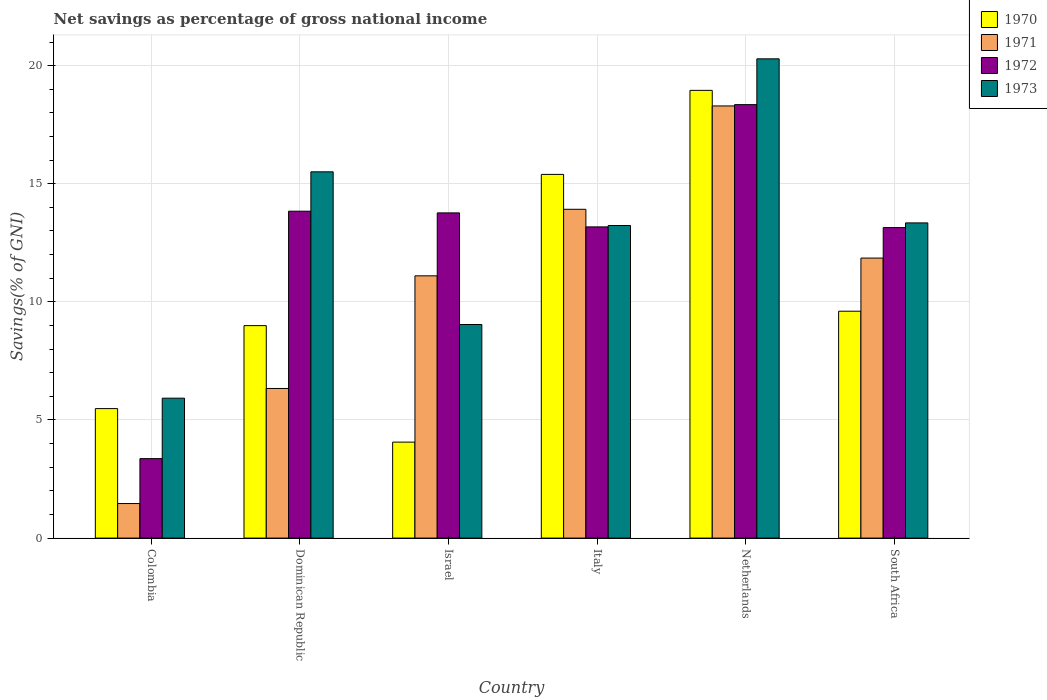How many different coloured bars are there?
Your answer should be compact. 4. Are the number of bars on each tick of the X-axis equal?
Make the answer very short. Yes. What is the label of the 2nd group of bars from the left?
Provide a succinct answer. Dominican Republic. What is the total savings in 1970 in Colombia?
Provide a succinct answer. 5.48. Across all countries, what is the maximum total savings in 1972?
Keep it short and to the point. 18.35. Across all countries, what is the minimum total savings in 1970?
Make the answer very short. 4.06. In which country was the total savings in 1971 maximum?
Provide a short and direct response. Netherlands. What is the total total savings in 1970 in the graph?
Your answer should be compact. 62.49. What is the difference between the total savings in 1973 in Colombia and that in Italy?
Provide a succinct answer. -7.31. What is the difference between the total savings in 1973 in Colombia and the total savings in 1970 in Dominican Republic?
Offer a terse response. -3.07. What is the average total savings in 1970 per country?
Your answer should be very brief. 10.42. What is the difference between the total savings of/in 1973 and total savings of/in 1970 in Colombia?
Make the answer very short. 0.44. What is the ratio of the total savings in 1972 in Colombia to that in South Africa?
Provide a short and direct response. 0.26. Is the total savings in 1970 in Italy less than that in Netherlands?
Your answer should be compact. Yes. What is the difference between the highest and the second highest total savings in 1970?
Your response must be concise. -9.35. What is the difference between the highest and the lowest total savings in 1973?
Provide a short and direct response. 14.36. Is the sum of the total savings in 1973 in Colombia and Israel greater than the maximum total savings in 1970 across all countries?
Make the answer very short. No. Is it the case that in every country, the sum of the total savings in 1971 and total savings in 1973 is greater than the sum of total savings in 1970 and total savings in 1972?
Offer a terse response. No. What does the 4th bar from the left in South Africa represents?
Keep it short and to the point. 1973. Are the values on the major ticks of Y-axis written in scientific E-notation?
Make the answer very short. No. What is the title of the graph?
Your answer should be compact. Net savings as percentage of gross national income. Does "2014" appear as one of the legend labels in the graph?
Your answer should be compact. No. What is the label or title of the Y-axis?
Ensure brevity in your answer.  Savings(% of GNI). What is the Savings(% of GNI) in 1970 in Colombia?
Offer a terse response. 5.48. What is the Savings(% of GNI) of 1971 in Colombia?
Provide a short and direct response. 1.46. What is the Savings(% of GNI) in 1972 in Colombia?
Your answer should be compact. 3.36. What is the Savings(% of GNI) in 1973 in Colombia?
Your answer should be compact. 5.92. What is the Savings(% of GNI) of 1970 in Dominican Republic?
Make the answer very short. 8.99. What is the Savings(% of GNI) in 1971 in Dominican Republic?
Provide a short and direct response. 6.33. What is the Savings(% of GNI) of 1972 in Dominican Republic?
Provide a short and direct response. 13.84. What is the Savings(% of GNI) in 1973 in Dominican Republic?
Offer a very short reply. 15.5. What is the Savings(% of GNI) of 1970 in Israel?
Your response must be concise. 4.06. What is the Savings(% of GNI) of 1971 in Israel?
Offer a very short reply. 11.1. What is the Savings(% of GNI) in 1972 in Israel?
Offer a very short reply. 13.77. What is the Savings(% of GNI) in 1973 in Israel?
Your response must be concise. 9.04. What is the Savings(% of GNI) of 1970 in Italy?
Make the answer very short. 15.4. What is the Savings(% of GNI) of 1971 in Italy?
Keep it short and to the point. 13.92. What is the Savings(% of GNI) of 1972 in Italy?
Offer a very short reply. 13.17. What is the Savings(% of GNI) in 1973 in Italy?
Your answer should be very brief. 13.23. What is the Savings(% of GNI) of 1970 in Netherlands?
Give a very brief answer. 18.95. What is the Savings(% of GNI) in 1971 in Netherlands?
Offer a very short reply. 18.29. What is the Savings(% of GNI) of 1972 in Netherlands?
Offer a terse response. 18.35. What is the Savings(% of GNI) of 1973 in Netherlands?
Your answer should be very brief. 20.29. What is the Savings(% of GNI) in 1970 in South Africa?
Your answer should be compact. 9.6. What is the Savings(% of GNI) of 1971 in South Africa?
Ensure brevity in your answer.  11.85. What is the Savings(% of GNI) in 1972 in South Africa?
Offer a terse response. 13.14. What is the Savings(% of GNI) of 1973 in South Africa?
Give a very brief answer. 13.34. Across all countries, what is the maximum Savings(% of GNI) in 1970?
Your response must be concise. 18.95. Across all countries, what is the maximum Savings(% of GNI) of 1971?
Your answer should be very brief. 18.29. Across all countries, what is the maximum Savings(% of GNI) of 1972?
Make the answer very short. 18.35. Across all countries, what is the maximum Savings(% of GNI) of 1973?
Provide a short and direct response. 20.29. Across all countries, what is the minimum Savings(% of GNI) of 1970?
Make the answer very short. 4.06. Across all countries, what is the minimum Savings(% of GNI) of 1971?
Your answer should be compact. 1.46. Across all countries, what is the minimum Savings(% of GNI) in 1972?
Offer a terse response. 3.36. Across all countries, what is the minimum Savings(% of GNI) of 1973?
Your answer should be very brief. 5.92. What is the total Savings(% of GNI) of 1970 in the graph?
Your response must be concise. 62.49. What is the total Savings(% of GNI) in 1971 in the graph?
Offer a very short reply. 62.96. What is the total Savings(% of GNI) in 1972 in the graph?
Keep it short and to the point. 75.63. What is the total Savings(% of GNI) of 1973 in the graph?
Provide a short and direct response. 77.33. What is the difference between the Savings(% of GNI) in 1970 in Colombia and that in Dominican Republic?
Your answer should be very brief. -3.51. What is the difference between the Savings(% of GNI) of 1971 in Colombia and that in Dominican Republic?
Your answer should be very brief. -4.87. What is the difference between the Savings(% of GNI) in 1972 in Colombia and that in Dominican Republic?
Your answer should be compact. -10.47. What is the difference between the Savings(% of GNI) in 1973 in Colombia and that in Dominican Republic?
Your answer should be compact. -9.58. What is the difference between the Savings(% of GNI) of 1970 in Colombia and that in Israel?
Keep it short and to the point. 1.42. What is the difference between the Savings(% of GNI) of 1971 in Colombia and that in Israel?
Keep it short and to the point. -9.64. What is the difference between the Savings(% of GNI) in 1972 in Colombia and that in Israel?
Ensure brevity in your answer.  -10.4. What is the difference between the Savings(% of GNI) in 1973 in Colombia and that in Israel?
Ensure brevity in your answer.  -3.12. What is the difference between the Savings(% of GNI) in 1970 in Colombia and that in Italy?
Your answer should be very brief. -9.91. What is the difference between the Savings(% of GNI) of 1971 in Colombia and that in Italy?
Make the answer very short. -12.46. What is the difference between the Savings(% of GNI) of 1972 in Colombia and that in Italy?
Offer a terse response. -9.81. What is the difference between the Savings(% of GNI) in 1973 in Colombia and that in Italy?
Offer a terse response. -7.31. What is the difference between the Savings(% of GNI) in 1970 in Colombia and that in Netherlands?
Ensure brevity in your answer.  -13.47. What is the difference between the Savings(% of GNI) in 1971 in Colombia and that in Netherlands?
Ensure brevity in your answer.  -16.83. What is the difference between the Savings(% of GNI) of 1972 in Colombia and that in Netherlands?
Your answer should be very brief. -14.99. What is the difference between the Savings(% of GNI) of 1973 in Colombia and that in Netherlands?
Your response must be concise. -14.36. What is the difference between the Savings(% of GNI) of 1970 in Colombia and that in South Africa?
Make the answer very short. -4.12. What is the difference between the Savings(% of GNI) in 1971 in Colombia and that in South Africa?
Provide a short and direct response. -10.39. What is the difference between the Savings(% of GNI) of 1972 in Colombia and that in South Africa?
Your response must be concise. -9.78. What is the difference between the Savings(% of GNI) in 1973 in Colombia and that in South Africa?
Keep it short and to the point. -7.42. What is the difference between the Savings(% of GNI) in 1970 in Dominican Republic and that in Israel?
Keep it short and to the point. 4.93. What is the difference between the Savings(% of GNI) of 1971 in Dominican Republic and that in Israel?
Your answer should be compact. -4.77. What is the difference between the Savings(% of GNI) of 1972 in Dominican Republic and that in Israel?
Provide a short and direct response. 0.07. What is the difference between the Savings(% of GNI) in 1973 in Dominican Republic and that in Israel?
Your answer should be very brief. 6.46. What is the difference between the Savings(% of GNI) in 1970 in Dominican Republic and that in Italy?
Your answer should be compact. -6.4. What is the difference between the Savings(% of GNI) of 1971 in Dominican Republic and that in Italy?
Offer a very short reply. -7.59. What is the difference between the Savings(% of GNI) of 1972 in Dominican Republic and that in Italy?
Your response must be concise. 0.66. What is the difference between the Savings(% of GNI) in 1973 in Dominican Republic and that in Italy?
Offer a terse response. 2.27. What is the difference between the Savings(% of GNI) in 1970 in Dominican Republic and that in Netherlands?
Make the answer very short. -9.96. What is the difference between the Savings(% of GNI) in 1971 in Dominican Republic and that in Netherlands?
Your response must be concise. -11.96. What is the difference between the Savings(% of GNI) of 1972 in Dominican Republic and that in Netherlands?
Give a very brief answer. -4.51. What is the difference between the Savings(% of GNI) in 1973 in Dominican Republic and that in Netherlands?
Keep it short and to the point. -4.78. What is the difference between the Savings(% of GNI) of 1970 in Dominican Republic and that in South Africa?
Your response must be concise. -0.61. What is the difference between the Savings(% of GNI) of 1971 in Dominican Republic and that in South Africa?
Offer a terse response. -5.52. What is the difference between the Savings(% of GNI) of 1972 in Dominican Republic and that in South Africa?
Provide a succinct answer. 0.69. What is the difference between the Savings(% of GNI) of 1973 in Dominican Republic and that in South Africa?
Keep it short and to the point. 2.16. What is the difference between the Savings(% of GNI) of 1970 in Israel and that in Italy?
Make the answer very short. -11.33. What is the difference between the Savings(% of GNI) of 1971 in Israel and that in Italy?
Your answer should be very brief. -2.82. What is the difference between the Savings(% of GNI) of 1972 in Israel and that in Italy?
Ensure brevity in your answer.  0.59. What is the difference between the Savings(% of GNI) in 1973 in Israel and that in Italy?
Offer a very short reply. -4.19. What is the difference between the Savings(% of GNI) in 1970 in Israel and that in Netherlands?
Your response must be concise. -14.89. What is the difference between the Savings(% of GNI) of 1971 in Israel and that in Netherlands?
Offer a terse response. -7.19. What is the difference between the Savings(% of GNI) in 1972 in Israel and that in Netherlands?
Keep it short and to the point. -4.58. What is the difference between the Savings(% of GNI) of 1973 in Israel and that in Netherlands?
Ensure brevity in your answer.  -11.25. What is the difference between the Savings(% of GNI) of 1970 in Israel and that in South Africa?
Make the answer very short. -5.54. What is the difference between the Savings(% of GNI) of 1971 in Israel and that in South Africa?
Offer a very short reply. -0.75. What is the difference between the Savings(% of GNI) of 1972 in Israel and that in South Africa?
Ensure brevity in your answer.  0.62. What is the difference between the Savings(% of GNI) in 1973 in Israel and that in South Africa?
Ensure brevity in your answer.  -4.3. What is the difference between the Savings(% of GNI) in 1970 in Italy and that in Netherlands?
Make the answer very short. -3.56. What is the difference between the Savings(% of GNI) in 1971 in Italy and that in Netherlands?
Make the answer very short. -4.37. What is the difference between the Savings(% of GNI) in 1972 in Italy and that in Netherlands?
Ensure brevity in your answer.  -5.18. What is the difference between the Savings(% of GNI) in 1973 in Italy and that in Netherlands?
Offer a very short reply. -7.06. What is the difference between the Savings(% of GNI) of 1970 in Italy and that in South Africa?
Make the answer very short. 5.79. What is the difference between the Savings(% of GNI) of 1971 in Italy and that in South Africa?
Offer a terse response. 2.07. What is the difference between the Savings(% of GNI) in 1972 in Italy and that in South Africa?
Your answer should be very brief. 0.03. What is the difference between the Savings(% of GNI) in 1973 in Italy and that in South Africa?
Keep it short and to the point. -0.11. What is the difference between the Savings(% of GNI) in 1970 in Netherlands and that in South Africa?
Make the answer very short. 9.35. What is the difference between the Savings(% of GNI) in 1971 in Netherlands and that in South Africa?
Your response must be concise. 6.44. What is the difference between the Savings(% of GNI) of 1972 in Netherlands and that in South Africa?
Provide a short and direct response. 5.21. What is the difference between the Savings(% of GNI) of 1973 in Netherlands and that in South Africa?
Give a very brief answer. 6.95. What is the difference between the Savings(% of GNI) of 1970 in Colombia and the Savings(% of GNI) of 1971 in Dominican Republic?
Ensure brevity in your answer.  -0.85. What is the difference between the Savings(% of GNI) in 1970 in Colombia and the Savings(% of GNI) in 1972 in Dominican Republic?
Give a very brief answer. -8.36. What is the difference between the Savings(% of GNI) in 1970 in Colombia and the Savings(% of GNI) in 1973 in Dominican Republic?
Keep it short and to the point. -10.02. What is the difference between the Savings(% of GNI) in 1971 in Colombia and the Savings(% of GNI) in 1972 in Dominican Republic?
Your response must be concise. -12.38. What is the difference between the Savings(% of GNI) in 1971 in Colombia and the Savings(% of GNI) in 1973 in Dominican Republic?
Provide a short and direct response. -14.04. What is the difference between the Savings(% of GNI) in 1972 in Colombia and the Savings(% of GNI) in 1973 in Dominican Republic?
Make the answer very short. -12.14. What is the difference between the Savings(% of GNI) in 1970 in Colombia and the Savings(% of GNI) in 1971 in Israel?
Offer a terse response. -5.62. What is the difference between the Savings(% of GNI) in 1970 in Colombia and the Savings(% of GNI) in 1972 in Israel?
Your answer should be compact. -8.28. What is the difference between the Savings(% of GNI) of 1970 in Colombia and the Savings(% of GNI) of 1973 in Israel?
Your answer should be compact. -3.56. What is the difference between the Savings(% of GNI) in 1971 in Colombia and the Savings(% of GNI) in 1972 in Israel?
Ensure brevity in your answer.  -12.3. What is the difference between the Savings(% of GNI) of 1971 in Colombia and the Savings(% of GNI) of 1973 in Israel?
Give a very brief answer. -7.58. What is the difference between the Savings(% of GNI) in 1972 in Colombia and the Savings(% of GNI) in 1973 in Israel?
Give a very brief answer. -5.68. What is the difference between the Savings(% of GNI) of 1970 in Colombia and the Savings(% of GNI) of 1971 in Italy?
Keep it short and to the point. -8.44. What is the difference between the Savings(% of GNI) in 1970 in Colombia and the Savings(% of GNI) in 1972 in Italy?
Give a very brief answer. -7.69. What is the difference between the Savings(% of GNI) of 1970 in Colombia and the Savings(% of GNI) of 1973 in Italy?
Offer a terse response. -7.75. What is the difference between the Savings(% of GNI) in 1971 in Colombia and the Savings(% of GNI) in 1972 in Italy?
Your answer should be compact. -11.71. What is the difference between the Savings(% of GNI) in 1971 in Colombia and the Savings(% of GNI) in 1973 in Italy?
Keep it short and to the point. -11.77. What is the difference between the Savings(% of GNI) of 1972 in Colombia and the Savings(% of GNI) of 1973 in Italy?
Provide a short and direct response. -9.87. What is the difference between the Savings(% of GNI) in 1970 in Colombia and the Savings(% of GNI) in 1971 in Netherlands?
Provide a succinct answer. -12.81. What is the difference between the Savings(% of GNI) in 1970 in Colombia and the Savings(% of GNI) in 1972 in Netherlands?
Offer a terse response. -12.87. What is the difference between the Savings(% of GNI) of 1970 in Colombia and the Savings(% of GNI) of 1973 in Netherlands?
Offer a terse response. -14.81. What is the difference between the Savings(% of GNI) in 1971 in Colombia and the Savings(% of GNI) in 1972 in Netherlands?
Make the answer very short. -16.89. What is the difference between the Savings(% of GNI) of 1971 in Colombia and the Savings(% of GNI) of 1973 in Netherlands?
Offer a terse response. -18.83. What is the difference between the Savings(% of GNI) of 1972 in Colombia and the Savings(% of GNI) of 1973 in Netherlands?
Give a very brief answer. -16.92. What is the difference between the Savings(% of GNI) of 1970 in Colombia and the Savings(% of GNI) of 1971 in South Africa?
Your answer should be very brief. -6.37. What is the difference between the Savings(% of GNI) in 1970 in Colombia and the Savings(% of GNI) in 1972 in South Africa?
Offer a very short reply. -7.66. What is the difference between the Savings(% of GNI) of 1970 in Colombia and the Savings(% of GNI) of 1973 in South Africa?
Provide a succinct answer. -7.86. What is the difference between the Savings(% of GNI) in 1971 in Colombia and the Savings(% of GNI) in 1972 in South Africa?
Ensure brevity in your answer.  -11.68. What is the difference between the Savings(% of GNI) in 1971 in Colombia and the Savings(% of GNI) in 1973 in South Africa?
Offer a very short reply. -11.88. What is the difference between the Savings(% of GNI) in 1972 in Colombia and the Savings(% of GNI) in 1973 in South Africa?
Offer a terse response. -9.98. What is the difference between the Savings(% of GNI) in 1970 in Dominican Republic and the Savings(% of GNI) in 1971 in Israel?
Keep it short and to the point. -2.11. What is the difference between the Savings(% of GNI) of 1970 in Dominican Republic and the Savings(% of GNI) of 1972 in Israel?
Your answer should be very brief. -4.77. What is the difference between the Savings(% of GNI) in 1970 in Dominican Republic and the Savings(% of GNI) in 1973 in Israel?
Your answer should be compact. -0.05. What is the difference between the Savings(% of GNI) in 1971 in Dominican Republic and the Savings(% of GNI) in 1972 in Israel?
Offer a very short reply. -7.43. What is the difference between the Savings(% of GNI) in 1971 in Dominican Republic and the Savings(% of GNI) in 1973 in Israel?
Ensure brevity in your answer.  -2.71. What is the difference between the Savings(% of GNI) in 1972 in Dominican Republic and the Savings(% of GNI) in 1973 in Israel?
Your answer should be compact. 4.8. What is the difference between the Savings(% of GNI) in 1970 in Dominican Republic and the Savings(% of GNI) in 1971 in Italy?
Ensure brevity in your answer.  -4.93. What is the difference between the Savings(% of GNI) in 1970 in Dominican Republic and the Savings(% of GNI) in 1972 in Italy?
Keep it short and to the point. -4.18. What is the difference between the Savings(% of GNI) in 1970 in Dominican Republic and the Savings(% of GNI) in 1973 in Italy?
Provide a short and direct response. -4.24. What is the difference between the Savings(% of GNI) of 1971 in Dominican Republic and the Savings(% of GNI) of 1972 in Italy?
Give a very brief answer. -6.84. What is the difference between the Savings(% of GNI) of 1971 in Dominican Republic and the Savings(% of GNI) of 1973 in Italy?
Offer a terse response. -6.9. What is the difference between the Savings(% of GNI) of 1972 in Dominican Republic and the Savings(% of GNI) of 1973 in Italy?
Your answer should be compact. 0.61. What is the difference between the Savings(% of GNI) in 1970 in Dominican Republic and the Savings(% of GNI) in 1971 in Netherlands?
Ensure brevity in your answer.  -9.3. What is the difference between the Savings(% of GNI) in 1970 in Dominican Republic and the Savings(% of GNI) in 1972 in Netherlands?
Provide a succinct answer. -9.36. What is the difference between the Savings(% of GNI) in 1970 in Dominican Republic and the Savings(% of GNI) in 1973 in Netherlands?
Offer a very short reply. -11.29. What is the difference between the Savings(% of GNI) in 1971 in Dominican Republic and the Savings(% of GNI) in 1972 in Netherlands?
Offer a terse response. -12.02. What is the difference between the Savings(% of GNI) of 1971 in Dominican Republic and the Savings(% of GNI) of 1973 in Netherlands?
Provide a succinct answer. -13.95. What is the difference between the Savings(% of GNI) of 1972 in Dominican Republic and the Savings(% of GNI) of 1973 in Netherlands?
Keep it short and to the point. -6.45. What is the difference between the Savings(% of GNI) of 1970 in Dominican Republic and the Savings(% of GNI) of 1971 in South Africa?
Your answer should be very brief. -2.86. What is the difference between the Savings(% of GNI) of 1970 in Dominican Republic and the Savings(% of GNI) of 1972 in South Africa?
Make the answer very short. -4.15. What is the difference between the Savings(% of GNI) of 1970 in Dominican Republic and the Savings(% of GNI) of 1973 in South Africa?
Your answer should be compact. -4.35. What is the difference between the Savings(% of GNI) in 1971 in Dominican Republic and the Savings(% of GNI) in 1972 in South Africa?
Your answer should be very brief. -6.81. What is the difference between the Savings(% of GNI) of 1971 in Dominican Republic and the Savings(% of GNI) of 1973 in South Africa?
Your answer should be compact. -7.01. What is the difference between the Savings(% of GNI) in 1972 in Dominican Republic and the Savings(% of GNI) in 1973 in South Africa?
Ensure brevity in your answer.  0.5. What is the difference between the Savings(% of GNI) of 1970 in Israel and the Savings(% of GNI) of 1971 in Italy?
Give a very brief answer. -9.86. What is the difference between the Savings(% of GNI) of 1970 in Israel and the Savings(% of GNI) of 1972 in Italy?
Offer a terse response. -9.11. What is the difference between the Savings(% of GNI) in 1970 in Israel and the Savings(% of GNI) in 1973 in Italy?
Ensure brevity in your answer.  -9.17. What is the difference between the Savings(% of GNI) in 1971 in Israel and the Savings(% of GNI) in 1972 in Italy?
Your answer should be very brief. -2.07. What is the difference between the Savings(% of GNI) of 1971 in Israel and the Savings(% of GNI) of 1973 in Italy?
Your answer should be compact. -2.13. What is the difference between the Savings(% of GNI) in 1972 in Israel and the Savings(% of GNI) in 1973 in Italy?
Offer a terse response. 0.53. What is the difference between the Savings(% of GNI) in 1970 in Israel and the Savings(% of GNI) in 1971 in Netherlands?
Keep it short and to the point. -14.23. What is the difference between the Savings(% of GNI) of 1970 in Israel and the Savings(% of GNI) of 1972 in Netherlands?
Ensure brevity in your answer.  -14.29. What is the difference between the Savings(% of GNI) in 1970 in Israel and the Savings(% of GNI) in 1973 in Netherlands?
Make the answer very short. -16.22. What is the difference between the Savings(% of GNI) in 1971 in Israel and the Savings(% of GNI) in 1972 in Netherlands?
Your response must be concise. -7.25. What is the difference between the Savings(% of GNI) in 1971 in Israel and the Savings(% of GNI) in 1973 in Netherlands?
Keep it short and to the point. -9.19. What is the difference between the Savings(% of GNI) in 1972 in Israel and the Savings(% of GNI) in 1973 in Netherlands?
Your answer should be compact. -6.52. What is the difference between the Savings(% of GNI) of 1970 in Israel and the Savings(% of GNI) of 1971 in South Africa?
Give a very brief answer. -7.79. What is the difference between the Savings(% of GNI) in 1970 in Israel and the Savings(% of GNI) in 1972 in South Africa?
Give a very brief answer. -9.08. What is the difference between the Savings(% of GNI) in 1970 in Israel and the Savings(% of GNI) in 1973 in South Africa?
Provide a short and direct response. -9.28. What is the difference between the Savings(% of GNI) in 1971 in Israel and the Savings(% of GNI) in 1972 in South Africa?
Your answer should be compact. -2.04. What is the difference between the Savings(% of GNI) of 1971 in Israel and the Savings(% of GNI) of 1973 in South Africa?
Your response must be concise. -2.24. What is the difference between the Savings(% of GNI) of 1972 in Israel and the Savings(% of GNI) of 1973 in South Africa?
Your answer should be compact. 0.42. What is the difference between the Savings(% of GNI) in 1970 in Italy and the Savings(% of GNI) in 1971 in Netherlands?
Offer a very short reply. -2.9. What is the difference between the Savings(% of GNI) of 1970 in Italy and the Savings(% of GNI) of 1972 in Netherlands?
Make the answer very short. -2.95. What is the difference between the Savings(% of GNI) of 1970 in Italy and the Savings(% of GNI) of 1973 in Netherlands?
Your answer should be very brief. -4.89. What is the difference between the Savings(% of GNI) of 1971 in Italy and the Savings(% of GNI) of 1972 in Netherlands?
Keep it short and to the point. -4.43. What is the difference between the Savings(% of GNI) in 1971 in Italy and the Savings(% of GNI) in 1973 in Netherlands?
Your answer should be compact. -6.37. What is the difference between the Savings(% of GNI) in 1972 in Italy and the Savings(% of GNI) in 1973 in Netherlands?
Make the answer very short. -7.11. What is the difference between the Savings(% of GNI) of 1970 in Italy and the Savings(% of GNI) of 1971 in South Africa?
Offer a terse response. 3.54. What is the difference between the Savings(% of GNI) in 1970 in Italy and the Savings(% of GNI) in 1972 in South Africa?
Offer a terse response. 2.25. What is the difference between the Savings(% of GNI) of 1970 in Italy and the Savings(% of GNI) of 1973 in South Africa?
Give a very brief answer. 2.05. What is the difference between the Savings(% of GNI) in 1971 in Italy and the Savings(% of GNI) in 1972 in South Africa?
Your response must be concise. 0.78. What is the difference between the Savings(% of GNI) of 1971 in Italy and the Savings(% of GNI) of 1973 in South Africa?
Give a very brief answer. 0.58. What is the difference between the Savings(% of GNI) of 1972 in Italy and the Savings(% of GNI) of 1973 in South Africa?
Your response must be concise. -0.17. What is the difference between the Savings(% of GNI) in 1970 in Netherlands and the Savings(% of GNI) in 1971 in South Africa?
Your answer should be compact. 7.1. What is the difference between the Savings(% of GNI) in 1970 in Netherlands and the Savings(% of GNI) in 1972 in South Africa?
Provide a short and direct response. 5.81. What is the difference between the Savings(% of GNI) of 1970 in Netherlands and the Savings(% of GNI) of 1973 in South Africa?
Your response must be concise. 5.61. What is the difference between the Savings(% of GNI) of 1971 in Netherlands and the Savings(% of GNI) of 1972 in South Africa?
Keep it short and to the point. 5.15. What is the difference between the Savings(% of GNI) in 1971 in Netherlands and the Savings(% of GNI) in 1973 in South Africa?
Give a very brief answer. 4.95. What is the difference between the Savings(% of GNI) in 1972 in Netherlands and the Savings(% of GNI) in 1973 in South Africa?
Your answer should be very brief. 5.01. What is the average Savings(% of GNI) of 1970 per country?
Keep it short and to the point. 10.42. What is the average Savings(% of GNI) of 1971 per country?
Ensure brevity in your answer.  10.49. What is the average Savings(% of GNI) of 1972 per country?
Give a very brief answer. 12.61. What is the average Savings(% of GNI) of 1973 per country?
Your answer should be very brief. 12.89. What is the difference between the Savings(% of GNI) in 1970 and Savings(% of GNI) in 1971 in Colombia?
Keep it short and to the point. 4.02. What is the difference between the Savings(% of GNI) in 1970 and Savings(% of GNI) in 1972 in Colombia?
Make the answer very short. 2.12. What is the difference between the Savings(% of GNI) of 1970 and Savings(% of GNI) of 1973 in Colombia?
Offer a terse response. -0.44. What is the difference between the Savings(% of GNI) in 1971 and Savings(% of GNI) in 1972 in Colombia?
Offer a very short reply. -1.9. What is the difference between the Savings(% of GNI) in 1971 and Savings(% of GNI) in 1973 in Colombia?
Ensure brevity in your answer.  -4.46. What is the difference between the Savings(% of GNI) of 1972 and Savings(% of GNI) of 1973 in Colombia?
Offer a terse response. -2.56. What is the difference between the Savings(% of GNI) in 1970 and Savings(% of GNI) in 1971 in Dominican Republic?
Your answer should be very brief. 2.66. What is the difference between the Savings(% of GNI) of 1970 and Savings(% of GNI) of 1972 in Dominican Republic?
Your answer should be compact. -4.84. What is the difference between the Savings(% of GNI) in 1970 and Savings(% of GNI) in 1973 in Dominican Republic?
Ensure brevity in your answer.  -6.51. What is the difference between the Savings(% of GNI) of 1971 and Savings(% of GNI) of 1972 in Dominican Republic?
Provide a succinct answer. -7.5. What is the difference between the Savings(% of GNI) of 1971 and Savings(% of GNI) of 1973 in Dominican Republic?
Keep it short and to the point. -9.17. What is the difference between the Savings(% of GNI) of 1972 and Savings(% of GNI) of 1973 in Dominican Republic?
Offer a very short reply. -1.67. What is the difference between the Savings(% of GNI) in 1970 and Savings(% of GNI) in 1971 in Israel?
Offer a terse response. -7.04. What is the difference between the Savings(% of GNI) in 1970 and Savings(% of GNI) in 1972 in Israel?
Your answer should be very brief. -9.7. What is the difference between the Savings(% of GNI) of 1970 and Savings(% of GNI) of 1973 in Israel?
Make the answer very short. -4.98. What is the difference between the Savings(% of GNI) of 1971 and Savings(% of GNI) of 1972 in Israel?
Keep it short and to the point. -2.66. What is the difference between the Savings(% of GNI) of 1971 and Savings(% of GNI) of 1973 in Israel?
Make the answer very short. 2.06. What is the difference between the Savings(% of GNI) of 1972 and Savings(% of GNI) of 1973 in Israel?
Give a very brief answer. 4.73. What is the difference between the Savings(% of GNI) of 1970 and Savings(% of GNI) of 1971 in Italy?
Ensure brevity in your answer.  1.48. What is the difference between the Savings(% of GNI) in 1970 and Savings(% of GNI) in 1972 in Italy?
Your response must be concise. 2.22. What is the difference between the Savings(% of GNI) in 1970 and Savings(% of GNI) in 1973 in Italy?
Offer a terse response. 2.16. What is the difference between the Savings(% of GNI) of 1971 and Savings(% of GNI) of 1972 in Italy?
Make the answer very short. 0.75. What is the difference between the Savings(% of GNI) of 1971 and Savings(% of GNI) of 1973 in Italy?
Give a very brief answer. 0.69. What is the difference between the Savings(% of GNI) in 1972 and Savings(% of GNI) in 1973 in Italy?
Keep it short and to the point. -0.06. What is the difference between the Savings(% of GNI) of 1970 and Savings(% of GNI) of 1971 in Netherlands?
Provide a succinct answer. 0.66. What is the difference between the Savings(% of GNI) in 1970 and Savings(% of GNI) in 1972 in Netherlands?
Offer a terse response. 0.6. What is the difference between the Savings(% of GNI) in 1970 and Savings(% of GNI) in 1973 in Netherlands?
Provide a succinct answer. -1.33. What is the difference between the Savings(% of GNI) in 1971 and Savings(% of GNI) in 1972 in Netherlands?
Offer a terse response. -0.06. What is the difference between the Savings(% of GNI) in 1971 and Savings(% of GNI) in 1973 in Netherlands?
Your answer should be very brief. -1.99. What is the difference between the Savings(% of GNI) of 1972 and Savings(% of GNI) of 1973 in Netherlands?
Give a very brief answer. -1.94. What is the difference between the Savings(% of GNI) in 1970 and Savings(% of GNI) in 1971 in South Africa?
Your answer should be compact. -2.25. What is the difference between the Savings(% of GNI) in 1970 and Savings(% of GNI) in 1972 in South Africa?
Offer a terse response. -3.54. What is the difference between the Savings(% of GNI) in 1970 and Savings(% of GNI) in 1973 in South Africa?
Offer a terse response. -3.74. What is the difference between the Savings(% of GNI) in 1971 and Savings(% of GNI) in 1972 in South Africa?
Your answer should be very brief. -1.29. What is the difference between the Savings(% of GNI) in 1971 and Savings(% of GNI) in 1973 in South Africa?
Provide a succinct answer. -1.49. What is the difference between the Savings(% of GNI) in 1972 and Savings(% of GNI) in 1973 in South Africa?
Provide a short and direct response. -0.2. What is the ratio of the Savings(% of GNI) of 1970 in Colombia to that in Dominican Republic?
Your answer should be compact. 0.61. What is the ratio of the Savings(% of GNI) of 1971 in Colombia to that in Dominican Republic?
Ensure brevity in your answer.  0.23. What is the ratio of the Savings(% of GNI) in 1972 in Colombia to that in Dominican Republic?
Your response must be concise. 0.24. What is the ratio of the Savings(% of GNI) in 1973 in Colombia to that in Dominican Republic?
Provide a short and direct response. 0.38. What is the ratio of the Savings(% of GNI) in 1970 in Colombia to that in Israel?
Provide a short and direct response. 1.35. What is the ratio of the Savings(% of GNI) in 1971 in Colombia to that in Israel?
Offer a terse response. 0.13. What is the ratio of the Savings(% of GNI) in 1972 in Colombia to that in Israel?
Your answer should be compact. 0.24. What is the ratio of the Savings(% of GNI) in 1973 in Colombia to that in Israel?
Your answer should be compact. 0.66. What is the ratio of the Savings(% of GNI) in 1970 in Colombia to that in Italy?
Your answer should be very brief. 0.36. What is the ratio of the Savings(% of GNI) in 1971 in Colombia to that in Italy?
Your response must be concise. 0.11. What is the ratio of the Savings(% of GNI) of 1972 in Colombia to that in Italy?
Give a very brief answer. 0.26. What is the ratio of the Savings(% of GNI) of 1973 in Colombia to that in Italy?
Offer a terse response. 0.45. What is the ratio of the Savings(% of GNI) in 1970 in Colombia to that in Netherlands?
Make the answer very short. 0.29. What is the ratio of the Savings(% of GNI) in 1971 in Colombia to that in Netherlands?
Make the answer very short. 0.08. What is the ratio of the Savings(% of GNI) in 1972 in Colombia to that in Netherlands?
Offer a very short reply. 0.18. What is the ratio of the Savings(% of GNI) of 1973 in Colombia to that in Netherlands?
Make the answer very short. 0.29. What is the ratio of the Savings(% of GNI) in 1970 in Colombia to that in South Africa?
Keep it short and to the point. 0.57. What is the ratio of the Savings(% of GNI) in 1971 in Colombia to that in South Africa?
Offer a terse response. 0.12. What is the ratio of the Savings(% of GNI) of 1972 in Colombia to that in South Africa?
Offer a terse response. 0.26. What is the ratio of the Savings(% of GNI) in 1973 in Colombia to that in South Africa?
Make the answer very short. 0.44. What is the ratio of the Savings(% of GNI) of 1970 in Dominican Republic to that in Israel?
Your answer should be very brief. 2.21. What is the ratio of the Savings(% of GNI) in 1971 in Dominican Republic to that in Israel?
Offer a terse response. 0.57. What is the ratio of the Savings(% of GNI) of 1972 in Dominican Republic to that in Israel?
Give a very brief answer. 1.01. What is the ratio of the Savings(% of GNI) in 1973 in Dominican Republic to that in Israel?
Make the answer very short. 1.71. What is the ratio of the Savings(% of GNI) in 1970 in Dominican Republic to that in Italy?
Your answer should be very brief. 0.58. What is the ratio of the Savings(% of GNI) in 1971 in Dominican Republic to that in Italy?
Make the answer very short. 0.46. What is the ratio of the Savings(% of GNI) of 1972 in Dominican Republic to that in Italy?
Keep it short and to the point. 1.05. What is the ratio of the Savings(% of GNI) of 1973 in Dominican Republic to that in Italy?
Your answer should be very brief. 1.17. What is the ratio of the Savings(% of GNI) of 1970 in Dominican Republic to that in Netherlands?
Provide a short and direct response. 0.47. What is the ratio of the Savings(% of GNI) of 1971 in Dominican Republic to that in Netherlands?
Your response must be concise. 0.35. What is the ratio of the Savings(% of GNI) in 1972 in Dominican Republic to that in Netherlands?
Keep it short and to the point. 0.75. What is the ratio of the Savings(% of GNI) in 1973 in Dominican Republic to that in Netherlands?
Your answer should be very brief. 0.76. What is the ratio of the Savings(% of GNI) of 1970 in Dominican Republic to that in South Africa?
Offer a terse response. 0.94. What is the ratio of the Savings(% of GNI) of 1971 in Dominican Republic to that in South Africa?
Your answer should be compact. 0.53. What is the ratio of the Savings(% of GNI) of 1972 in Dominican Republic to that in South Africa?
Ensure brevity in your answer.  1.05. What is the ratio of the Savings(% of GNI) of 1973 in Dominican Republic to that in South Africa?
Provide a succinct answer. 1.16. What is the ratio of the Savings(% of GNI) of 1970 in Israel to that in Italy?
Your answer should be very brief. 0.26. What is the ratio of the Savings(% of GNI) of 1971 in Israel to that in Italy?
Your answer should be compact. 0.8. What is the ratio of the Savings(% of GNI) in 1972 in Israel to that in Italy?
Keep it short and to the point. 1.04. What is the ratio of the Savings(% of GNI) in 1973 in Israel to that in Italy?
Give a very brief answer. 0.68. What is the ratio of the Savings(% of GNI) of 1970 in Israel to that in Netherlands?
Make the answer very short. 0.21. What is the ratio of the Savings(% of GNI) of 1971 in Israel to that in Netherlands?
Provide a short and direct response. 0.61. What is the ratio of the Savings(% of GNI) of 1972 in Israel to that in Netherlands?
Offer a very short reply. 0.75. What is the ratio of the Savings(% of GNI) of 1973 in Israel to that in Netherlands?
Your answer should be compact. 0.45. What is the ratio of the Savings(% of GNI) in 1970 in Israel to that in South Africa?
Your answer should be compact. 0.42. What is the ratio of the Savings(% of GNI) in 1971 in Israel to that in South Africa?
Your answer should be compact. 0.94. What is the ratio of the Savings(% of GNI) of 1972 in Israel to that in South Africa?
Provide a short and direct response. 1.05. What is the ratio of the Savings(% of GNI) of 1973 in Israel to that in South Africa?
Your response must be concise. 0.68. What is the ratio of the Savings(% of GNI) of 1970 in Italy to that in Netherlands?
Keep it short and to the point. 0.81. What is the ratio of the Savings(% of GNI) of 1971 in Italy to that in Netherlands?
Your answer should be compact. 0.76. What is the ratio of the Savings(% of GNI) in 1972 in Italy to that in Netherlands?
Provide a succinct answer. 0.72. What is the ratio of the Savings(% of GNI) in 1973 in Italy to that in Netherlands?
Offer a terse response. 0.65. What is the ratio of the Savings(% of GNI) in 1970 in Italy to that in South Africa?
Your answer should be compact. 1.6. What is the ratio of the Savings(% of GNI) of 1971 in Italy to that in South Africa?
Give a very brief answer. 1.17. What is the ratio of the Savings(% of GNI) in 1973 in Italy to that in South Africa?
Your answer should be compact. 0.99. What is the ratio of the Savings(% of GNI) in 1970 in Netherlands to that in South Africa?
Your response must be concise. 1.97. What is the ratio of the Savings(% of GNI) in 1971 in Netherlands to that in South Africa?
Give a very brief answer. 1.54. What is the ratio of the Savings(% of GNI) of 1972 in Netherlands to that in South Africa?
Provide a short and direct response. 1.4. What is the ratio of the Savings(% of GNI) of 1973 in Netherlands to that in South Africa?
Provide a short and direct response. 1.52. What is the difference between the highest and the second highest Savings(% of GNI) in 1970?
Your answer should be very brief. 3.56. What is the difference between the highest and the second highest Savings(% of GNI) of 1971?
Provide a short and direct response. 4.37. What is the difference between the highest and the second highest Savings(% of GNI) of 1972?
Give a very brief answer. 4.51. What is the difference between the highest and the second highest Savings(% of GNI) in 1973?
Your answer should be compact. 4.78. What is the difference between the highest and the lowest Savings(% of GNI) in 1970?
Ensure brevity in your answer.  14.89. What is the difference between the highest and the lowest Savings(% of GNI) in 1971?
Offer a terse response. 16.83. What is the difference between the highest and the lowest Savings(% of GNI) in 1972?
Your answer should be compact. 14.99. What is the difference between the highest and the lowest Savings(% of GNI) of 1973?
Offer a very short reply. 14.36. 